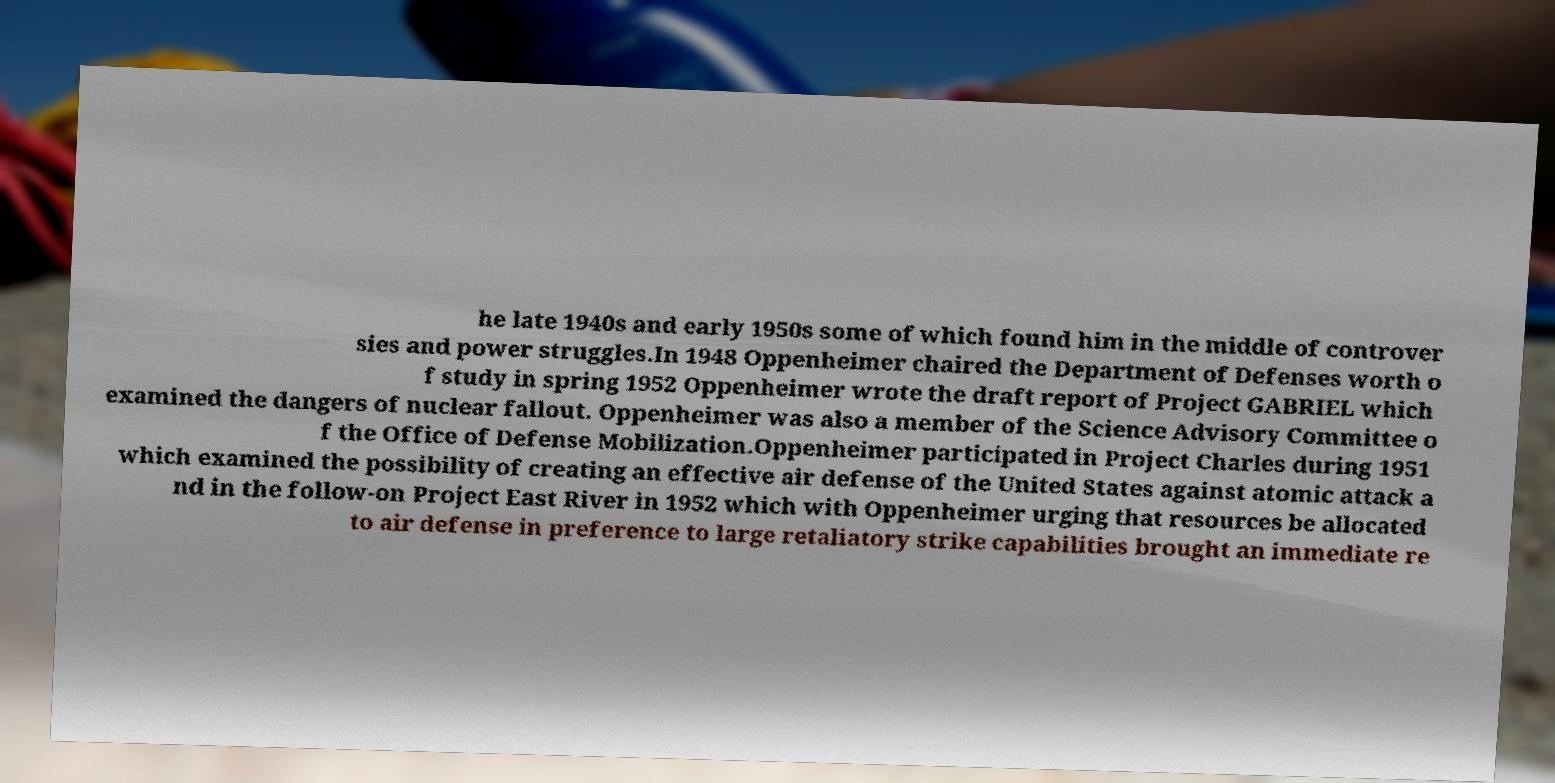There's text embedded in this image that I need extracted. Can you transcribe it verbatim? he late 1940s and early 1950s some of which found him in the middle of controver sies and power struggles.In 1948 Oppenheimer chaired the Department of Defenses worth o f study in spring 1952 Oppenheimer wrote the draft report of Project GABRIEL which examined the dangers of nuclear fallout. Oppenheimer was also a member of the Science Advisory Committee o f the Office of Defense Mobilization.Oppenheimer participated in Project Charles during 1951 which examined the possibility of creating an effective air defense of the United States against atomic attack a nd in the follow-on Project East River in 1952 which with Oppenheimer urging that resources be allocated to air defense in preference to large retaliatory strike capabilities brought an immediate re 